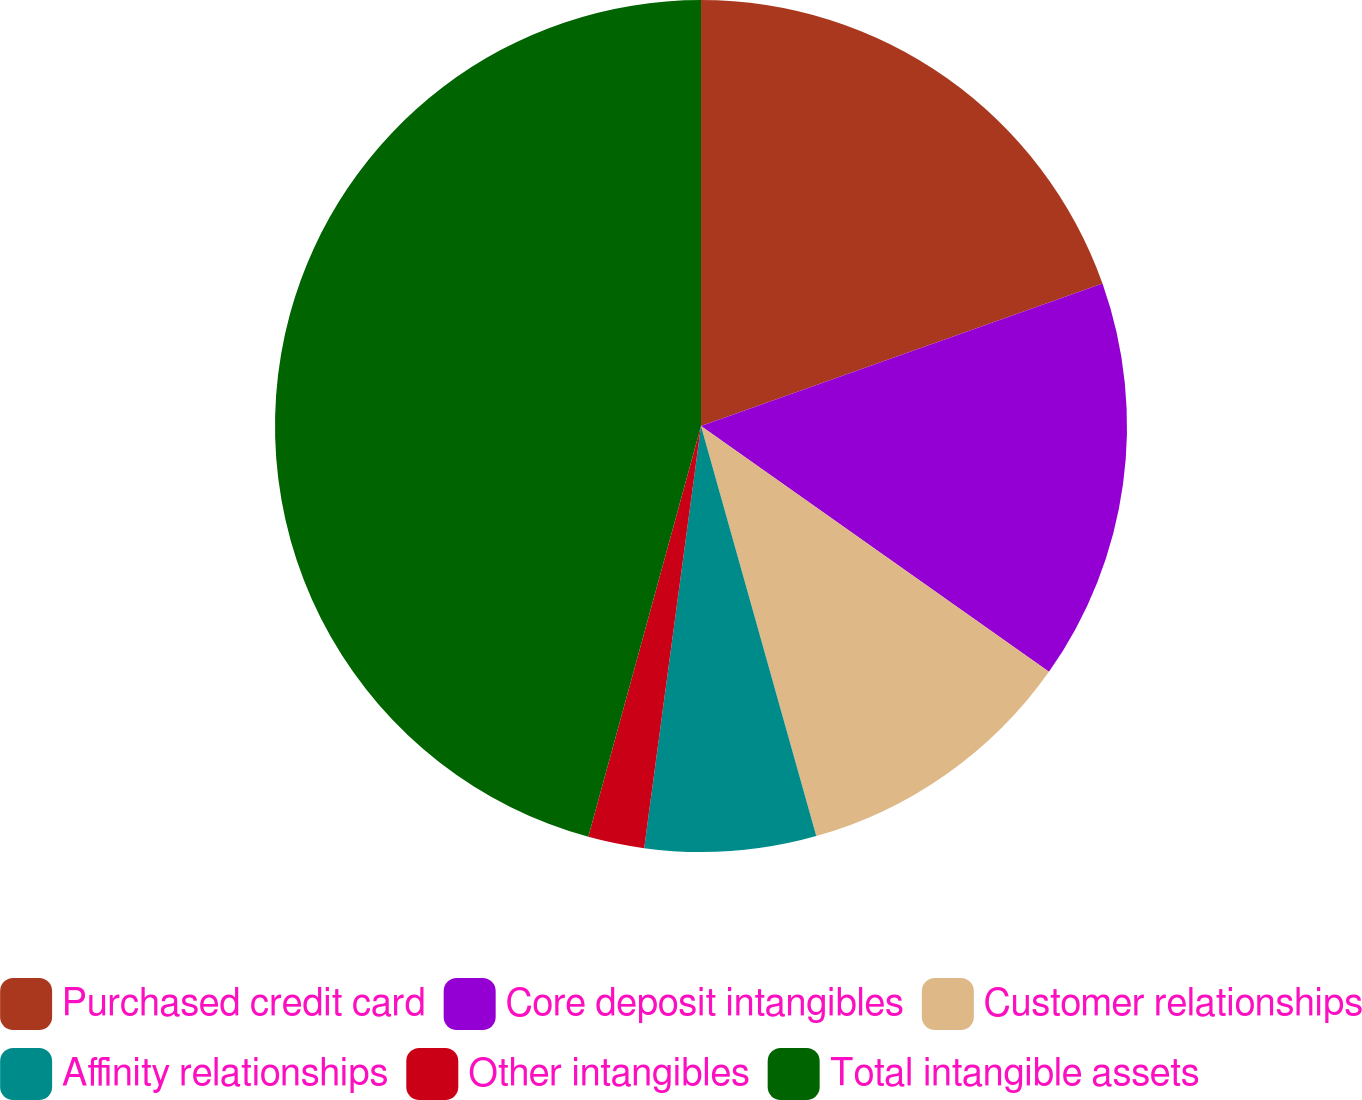<chart> <loc_0><loc_0><loc_500><loc_500><pie_chart><fcel>Purchased credit card<fcel>Core deposit intangibles<fcel>Customer relationships<fcel>Affinity relationships<fcel>Other intangibles<fcel>Total intangible assets<nl><fcel>19.57%<fcel>15.21%<fcel>10.85%<fcel>6.49%<fcel>2.13%<fcel>45.73%<nl></chart> 